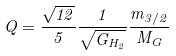<formula> <loc_0><loc_0><loc_500><loc_500>Q = \frac { \sqrt { 1 2 } } { 5 } \frac { 1 } { \sqrt { G _ { H _ { 2 } } } } \frac { m _ { 3 / 2 } } { M _ { G } }</formula> 